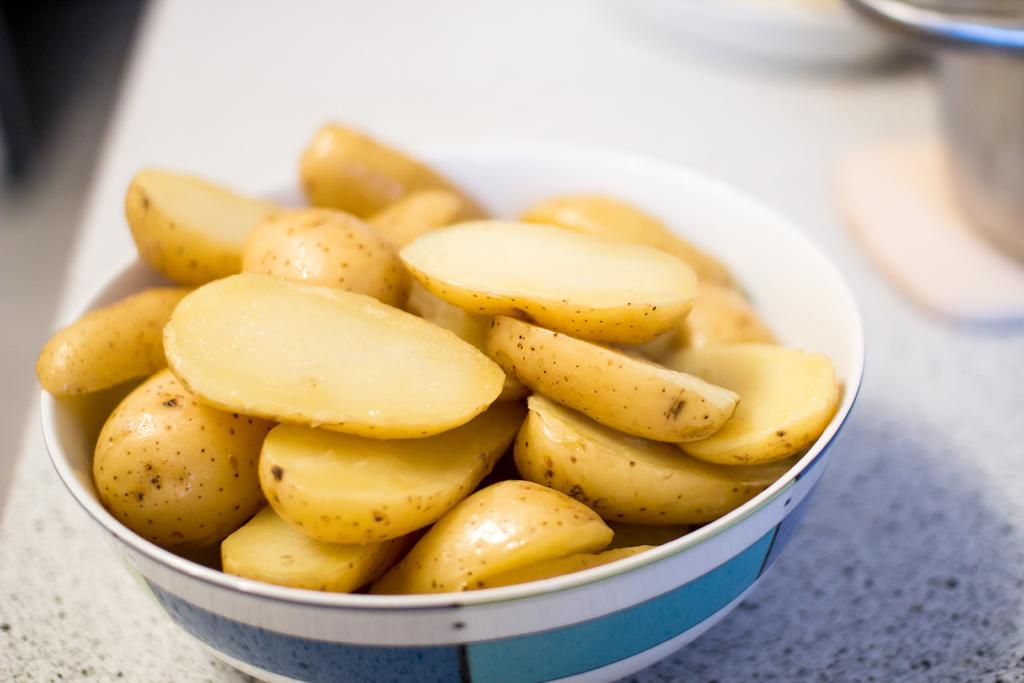What is in the bowl that is visible in the image? There is a bowl in the image containing potato slices. Where is the second bowl located in the image? There is another bowl on the right side top of the image, which is on the floor. What type of cake is being served in the image? There is no cake present in the image; it features a bowl of potato slices and another bowl on the floor. 